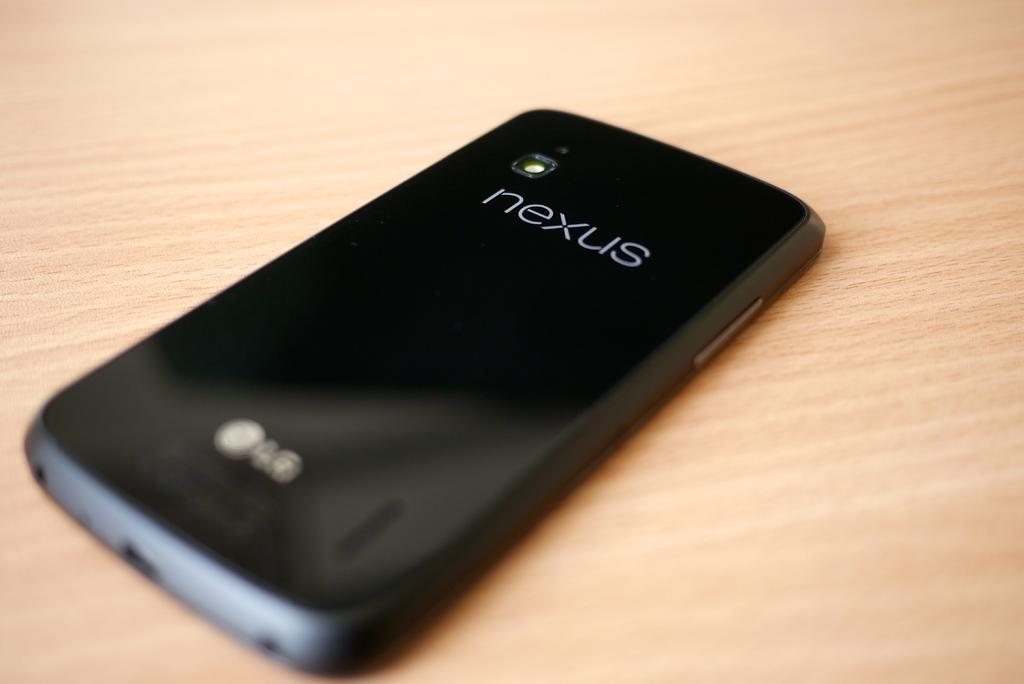<image>
Share a concise interpretation of the image provided. A nexus smart phone rests on a table top. 